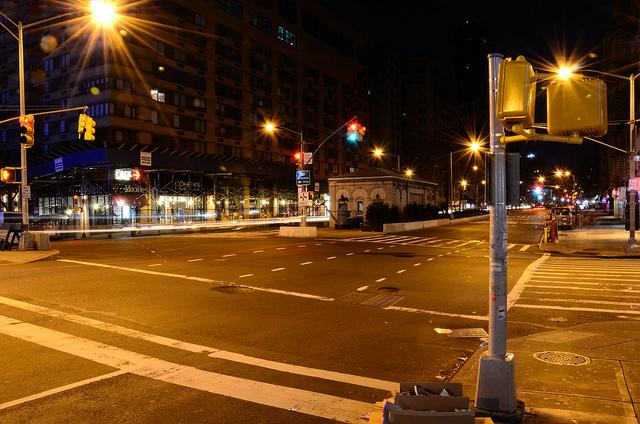How is the street staying illuminated? Please explain your reasoning. street lights. The streets are illuminated by street lights. 